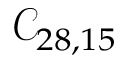Convert formula to latex. <formula><loc_0><loc_0><loc_500><loc_500>\mathcal { C } _ { 2 8 , 1 5 }</formula> 